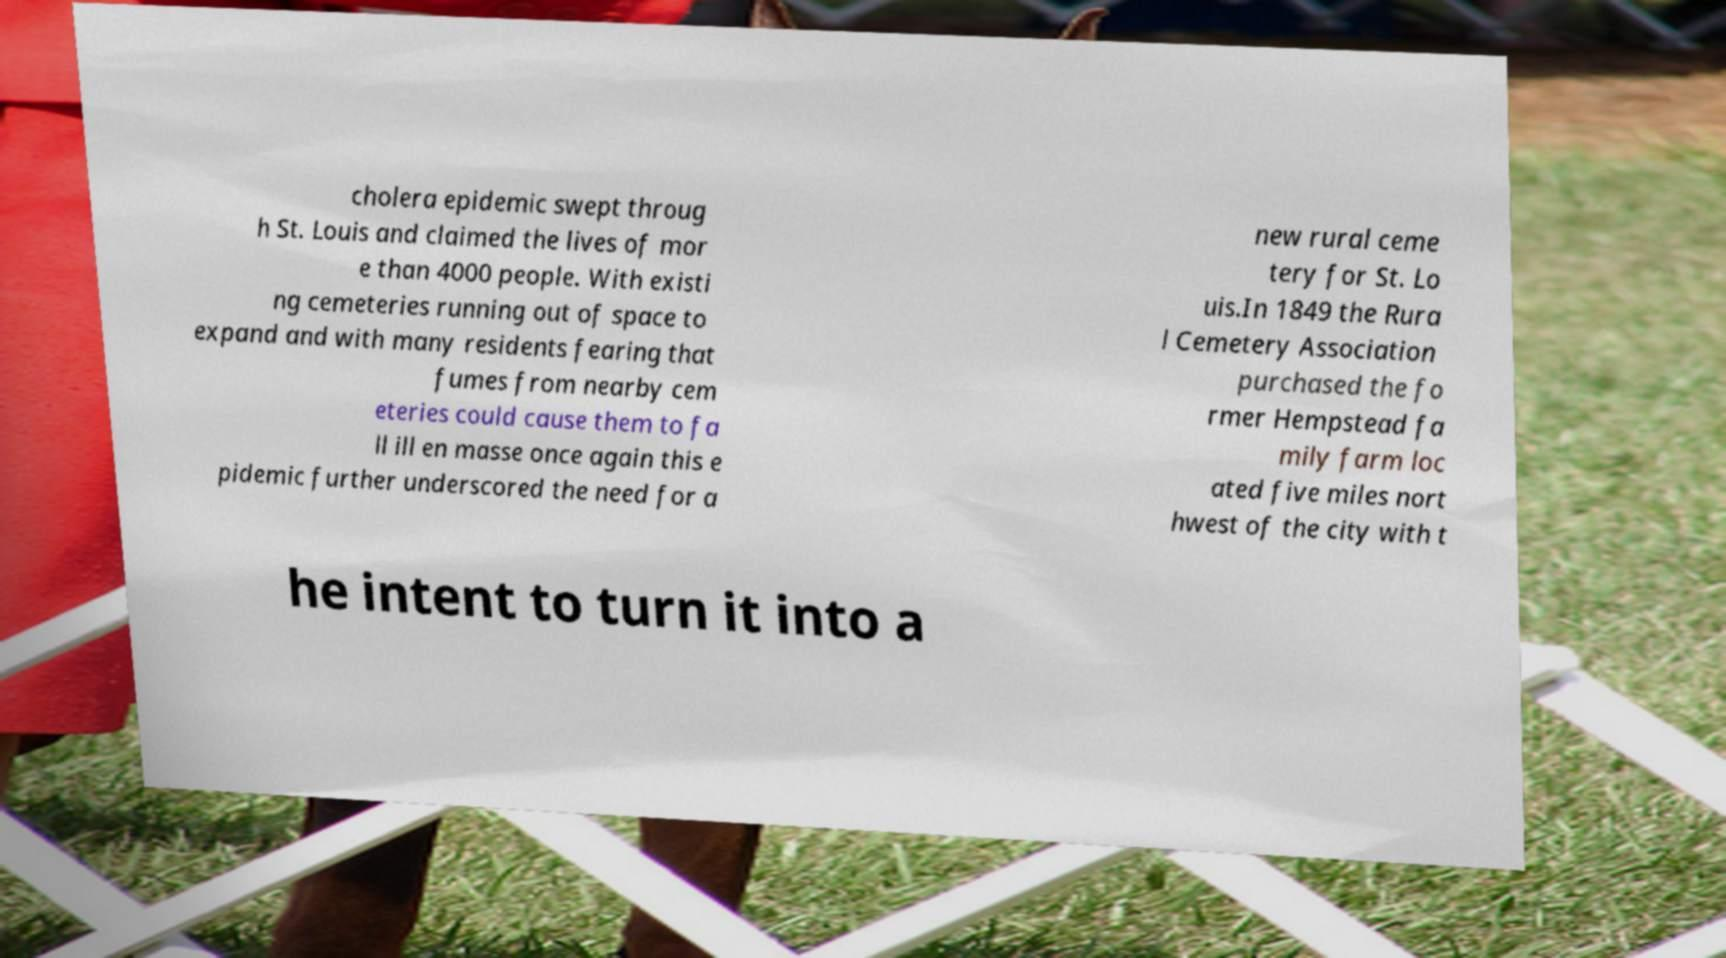Can you read and provide the text displayed in the image?This photo seems to have some interesting text. Can you extract and type it out for me? cholera epidemic swept throug h St. Louis and claimed the lives of mor e than 4000 people. With existi ng cemeteries running out of space to expand and with many residents fearing that fumes from nearby cem eteries could cause them to fa ll ill en masse once again this e pidemic further underscored the need for a new rural ceme tery for St. Lo uis.In 1849 the Rura l Cemetery Association purchased the fo rmer Hempstead fa mily farm loc ated five miles nort hwest of the city with t he intent to turn it into a 